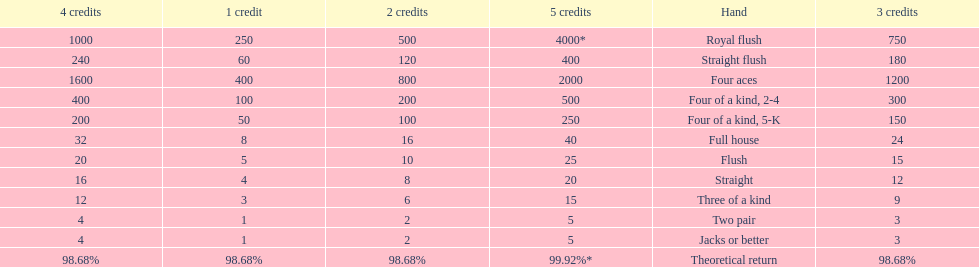What are the hands in super aces? Royal flush, Straight flush, Four aces, Four of a kind, 2-4, Four of a kind, 5-K, Full house, Flush, Straight, Three of a kind, Two pair, Jacks or better. What hand gives the highest credits? Royal flush. 